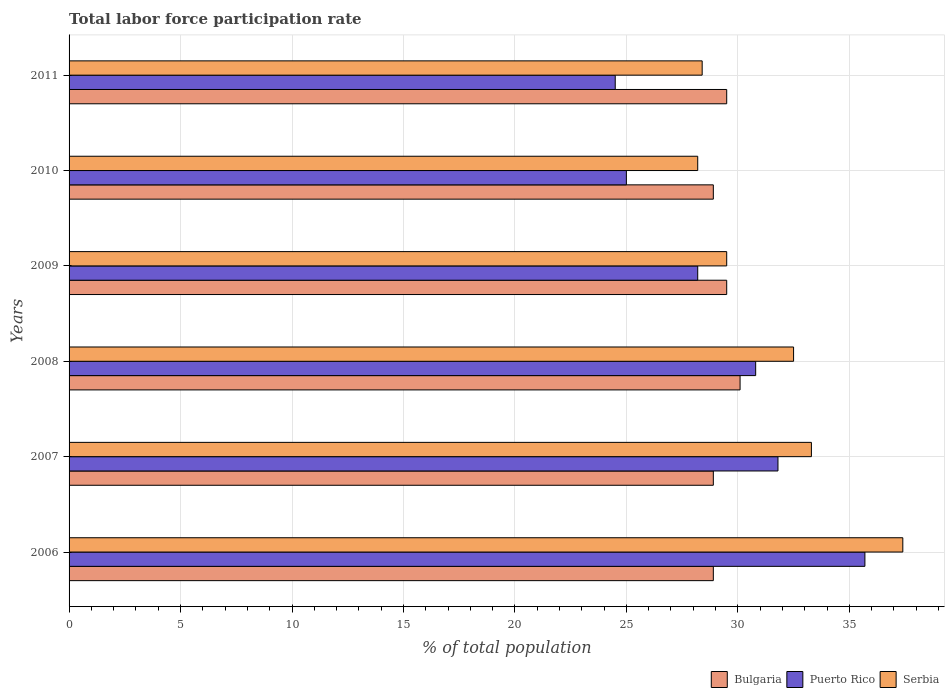How many different coloured bars are there?
Keep it short and to the point. 3. How many groups of bars are there?
Offer a very short reply. 6. How many bars are there on the 2nd tick from the top?
Your answer should be compact. 3. How many bars are there on the 6th tick from the bottom?
Keep it short and to the point. 3. What is the label of the 2nd group of bars from the top?
Provide a succinct answer. 2010. What is the total labor force participation rate in Puerto Rico in 2010?
Your response must be concise. 25. Across all years, what is the maximum total labor force participation rate in Serbia?
Make the answer very short. 37.4. Across all years, what is the minimum total labor force participation rate in Bulgaria?
Your answer should be compact. 28.9. In which year was the total labor force participation rate in Puerto Rico minimum?
Your answer should be compact. 2011. What is the total total labor force participation rate in Bulgaria in the graph?
Offer a terse response. 175.8. What is the difference between the total labor force participation rate in Bulgaria in 2010 and that in 2011?
Your answer should be very brief. -0.6. What is the difference between the total labor force participation rate in Puerto Rico in 2010 and the total labor force participation rate in Bulgaria in 2008?
Make the answer very short. -5.1. What is the average total labor force participation rate in Puerto Rico per year?
Ensure brevity in your answer.  29.33. In the year 2006, what is the difference between the total labor force participation rate in Serbia and total labor force participation rate in Bulgaria?
Keep it short and to the point. 8.5. In how many years, is the total labor force participation rate in Bulgaria greater than 15 %?
Offer a very short reply. 6. What is the ratio of the total labor force participation rate in Bulgaria in 2007 to that in 2011?
Your answer should be compact. 0.98. Is the total labor force participation rate in Serbia in 2006 less than that in 2010?
Provide a succinct answer. No. What is the difference between the highest and the second highest total labor force participation rate in Puerto Rico?
Provide a succinct answer. 3.9. What is the difference between the highest and the lowest total labor force participation rate in Puerto Rico?
Your answer should be very brief. 11.2. In how many years, is the total labor force participation rate in Bulgaria greater than the average total labor force participation rate in Bulgaria taken over all years?
Offer a terse response. 3. Is the sum of the total labor force participation rate in Puerto Rico in 2006 and 2010 greater than the maximum total labor force participation rate in Serbia across all years?
Give a very brief answer. Yes. What does the 1st bar from the top in 2008 represents?
Keep it short and to the point. Serbia. What does the 2nd bar from the bottom in 2007 represents?
Offer a terse response. Puerto Rico. How many bars are there?
Your answer should be very brief. 18. How many years are there in the graph?
Offer a very short reply. 6. What is the difference between two consecutive major ticks on the X-axis?
Your answer should be compact. 5. Where does the legend appear in the graph?
Keep it short and to the point. Bottom right. How are the legend labels stacked?
Ensure brevity in your answer.  Horizontal. What is the title of the graph?
Your answer should be very brief. Total labor force participation rate. What is the label or title of the X-axis?
Make the answer very short. % of total population. What is the % of total population of Bulgaria in 2006?
Make the answer very short. 28.9. What is the % of total population of Puerto Rico in 2006?
Provide a succinct answer. 35.7. What is the % of total population of Serbia in 2006?
Your response must be concise. 37.4. What is the % of total population in Bulgaria in 2007?
Your answer should be compact. 28.9. What is the % of total population in Puerto Rico in 2007?
Ensure brevity in your answer.  31.8. What is the % of total population in Serbia in 2007?
Ensure brevity in your answer.  33.3. What is the % of total population of Bulgaria in 2008?
Provide a succinct answer. 30.1. What is the % of total population of Puerto Rico in 2008?
Offer a very short reply. 30.8. What is the % of total population in Serbia in 2008?
Your answer should be very brief. 32.5. What is the % of total population in Bulgaria in 2009?
Ensure brevity in your answer.  29.5. What is the % of total population in Puerto Rico in 2009?
Ensure brevity in your answer.  28.2. What is the % of total population in Serbia in 2009?
Ensure brevity in your answer.  29.5. What is the % of total population of Bulgaria in 2010?
Offer a terse response. 28.9. What is the % of total population of Serbia in 2010?
Your answer should be very brief. 28.2. What is the % of total population in Bulgaria in 2011?
Offer a very short reply. 29.5. What is the % of total population in Serbia in 2011?
Offer a terse response. 28.4. Across all years, what is the maximum % of total population of Bulgaria?
Your response must be concise. 30.1. Across all years, what is the maximum % of total population of Puerto Rico?
Ensure brevity in your answer.  35.7. Across all years, what is the maximum % of total population of Serbia?
Keep it short and to the point. 37.4. Across all years, what is the minimum % of total population of Bulgaria?
Provide a short and direct response. 28.9. Across all years, what is the minimum % of total population of Puerto Rico?
Provide a succinct answer. 24.5. Across all years, what is the minimum % of total population of Serbia?
Your response must be concise. 28.2. What is the total % of total population of Bulgaria in the graph?
Offer a terse response. 175.8. What is the total % of total population of Puerto Rico in the graph?
Offer a very short reply. 176. What is the total % of total population of Serbia in the graph?
Ensure brevity in your answer.  189.3. What is the difference between the % of total population in Puerto Rico in 2006 and that in 2007?
Make the answer very short. 3.9. What is the difference between the % of total population of Puerto Rico in 2006 and that in 2009?
Give a very brief answer. 7.5. What is the difference between the % of total population of Serbia in 2006 and that in 2009?
Your answer should be compact. 7.9. What is the difference between the % of total population of Bulgaria in 2006 and that in 2010?
Your answer should be compact. 0. What is the difference between the % of total population of Puerto Rico in 2006 and that in 2010?
Provide a short and direct response. 10.7. What is the difference between the % of total population of Serbia in 2006 and that in 2010?
Offer a very short reply. 9.2. What is the difference between the % of total population of Puerto Rico in 2006 and that in 2011?
Ensure brevity in your answer.  11.2. What is the difference between the % of total population of Bulgaria in 2007 and that in 2008?
Your answer should be very brief. -1.2. What is the difference between the % of total population in Puerto Rico in 2007 and that in 2008?
Give a very brief answer. 1. What is the difference between the % of total population in Serbia in 2007 and that in 2008?
Make the answer very short. 0.8. What is the difference between the % of total population in Bulgaria in 2007 and that in 2009?
Your answer should be compact. -0.6. What is the difference between the % of total population in Puerto Rico in 2007 and that in 2009?
Ensure brevity in your answer.  3.6. What is the difference between the % of total population in Bulgaria in 2007 and that in 2010?
Make the answer very short. 0. What is the difference between the % of total population in Serbia in 2007 and that in 2010?
Ensure brevity in your answer.  5.1. What is the difference between the % of total population in Bulgaria in 2007 and that in 2011?
Your answer should be compact. -0.6. What is the difference between the % of total population in Puerto Rico in 2007 and that in 2011?
Offer a terse response. 7.3. What is the difference between the % of total population in Bulgaria in 2008 and that in 2009?
Make the answer very short. 0.6. What is the difference between the % of total population of Serbia in 2008 and that in 2009?
Your answer should be very brief. 3. What is the difference between the % of total population of Puerto Rico in 2008 and that in 2010?
Offer a terse response. 5.8. What is the difference between the % of total population of Bulgaria in 2008 and that in 2011?
Ensure brevity in your answer.  0.6. What is the difference between the % of total population of Serbia in 2009 and that in 2010?
Offer a terse response. 1.3. What is the difference between the % of total population of Puerto Rico in 2009 and that in 2011?
Offer a very short reply. 3.7. What is the difference between the % of total population of Serbia in 2009 and that in 2011?
Ensure brevity in your answer.  1.1. What is the difference between the % of total population in Bulgaria in 2010 and that in 2011?
Give a very brief answer. -0.6. What is the difference between the % of total population in Puerto Rico in 2006 and the % of total population in Serbia in 2007?
Offer a very short reply. 2.4. What is the difference between the % of total population of Bulgaria in 2006 and the % of total population of Serbia in 2008?
Offer a very short reply. -3.6. What is the difference between the % of total population of Puerto Rico in 2006 and the % of total population of Serbia in 2008?
Make the answer very short. 3.2. What is the difference between the % of total population of Bulgaria in 2006 and the % of total population of Puerto Rico in 2009?
Your answer should be very brief. 0.7. What is the difference between the % of total population in Bulgaria in 2006 and the % of total population in Serbia in 2009?
Your answer should be very brief. -0.6. What is the difference between the % of total population of Bulgaria in 2006 and the % of total population of Puerto Rico in 2010?
Your answer should be very brief. 3.9. What is the difference between the % of total population in Puerto Rico in 2006 and the % of total population in Serbia in 2010?
Your response must be concise. 7.5. What is the difference between the % of total population in Bulgaria in 2006 and the % of total population in Puerto Rico in 2011?
Give a very brief answer. 4.4. What is the difference between the % of total population of Bulgaria in 2006 and the % of total population of Serbia in 2011?
Your answer should be compact. 0.5. What is the difference between the % of total population of Puerto Rico in 2006 and the % of total population of Serbia in 2011?
Provide a short and direct response. 7.3. What is the difference between the % of total population in Puerto Rico in 2007 and the % of total population in Serbia in 2008?
Your answer should be compact. -0.7. What is the difference between the % of total population in Bulgaria in 2007 and the % of total population in Puerto Rico in 2009?
Offer a terse response. 0.7. What is the difference between the % of total population of Bulgaria in 2007 and the % of total population of Serbia in 2009?
Offer a very short reply. -0.6. What is the difference between the % of total population of Bulgaria in 2007 and the % of total population of Serbia in 2010?
Provide a short and direct response. 0.7. What is the difference between the % of total population in Bulgaria in 2008 and the % of total population in Serbia in 2009?
Provide a short and direct response. 0.6. What is the difference between the % of total population of Puerto Rico in 2008 and the % of total population of Serbia in 2009?
Offer a very short reply. 1.3. What is the difference between the % of total population of Bulgaria in 2008 and the % of total population of Serbia in 2010?
Ensure brevity in your answer.  1.9. What is the difference between the % of total population in Bulgaria in 2008 and the % of total population in Puerto Rico in 2011?
Provide a succinct answer. 5.6. What is the difference between the % of total population of Bulgaria in 2008 and the % of total population of Serbia in 2011?
Offer a terse response. 1.7. What is the difference between the % of total population of Puerto Rico in 2008 and the % of total population of Serbia in 2011?
Make the answer very short. 2.4. What is the difference between the % of total population in Bulgaria in 2009 and the % of total population in Puerto Rico in 2011?
Offer a very short reply. 5. What is the difference between the % of total population of Bulgaria in 2009 and the % of total population of Serbia in 2011?
Keep it short and to the point. 1.1. What is the difference between the % of total population in Puerto Rico in 2009 and the % of total population in Serbia in 2011?
Your answer should be very brief. -0.2. What is the difference between the % of total population of Puerto Rico in 2010 and the % of total population of Serbia in 2011?
Your answer should be very brief. -3.4. What is the average % of total population of Bulgaria per year?
Keep it short and to the point. 29.3. What is the average % of total population in Puerto Rico per year?
Provide a short and direct response. 29.33. What is the average % of total population of Serbia per year?
Make the answer very short. 31.55. In the year 2006, what is the difference between the % of total population in Bulgaria and % of total population in Puerto Rico?
Provide a short and direct response. -6.8. In the year 2006, what is the difference between the % of total population of Bulgaria and % of total population of Serbia?
Ensure brevity in your answer.  -8.5. In the year 2007, what is the difference between the % of total population in Bulgaria and % of total population in Puerto Rico?
Offer a very short reply. -2.9. In the year 2007, what is the difference between the % of total population of Bulgaria and % of total population of Serbia?
Your answer should be very brief. -4.4. In the year 2007, what is the difference between the % of total population in Puerto Rico and % of total population in Serbia?
Your answer should be very brief. -1.5. In the year 2008, what is the difference between the % of total population in Bulgaria and % of total population in Puerto Rico?
Your answer should be compact. -0.7. In the year 2008, what is the difference between the % of total population of Bulgaria and % of total population of Serbia?
Make the answer very short. -2.4. In the year 2010, what is the difference between the % of total population in Bulgaria and % of total population in Puerto Rico?
Your answer should be very brief. 3.9. In the year 2010, what is the difference between the % of total population of Bulgaria and % of total population of Serbia?
Provide a short and direct response. 0.7. In the year 2010, what is the difference between the % of total population of Puerto Rico and % of total population of Serbia?
Give a very brief answer. -3.2. In the year 2011, what is the difference between the % of total population of Puerto Rico and % of total population of Serbia?
Offer a very short reply. -3.9. What is the ratio of the % of total population in Puerto Rico in 2006 to that in 2007?
Provide a short and direct response. 1.12. What is the ratio of the % of total population in Serbia in 2006 to that in 2007?
Give a very brief answer. 1.12. What is the ratio of the % of total population of Bulgaria in 2006 to that in 2008?
Offer a very short reply. 0.96. What is the ratio of the % of total population of Puerto Rico in 2006 to that in 2008?
Keep it short and to the point. 1.16. What is the ratio of the % of total population of Serbia in 2006 to that in 2008?
Your answer should be very brief. 1.15. What is the ratio of the % of total population in Bulgaria in 2006 to that in 2009?
Provide a succinct answer. 0.98. What is the ratio of the % of total population of Puerto Rico in 2006 to that in 2009?
Give a very brief answer. 1.27. What is the ratio of the % of total population of Serbia in 2006 to that in 2009?
Provide a succinct answer. 1.27. What is the ratio of the % of total population of Bulgaria in 2006 to that in 2010?
Provide a succinct answer. 1. What is the ratio of the % of total population of Puerto Rico in 2006 to that in 2010?
Keep it short and to the point. 1.43. What is the ratio of the % of total population in Serbia in 2006 to that in 2010?
Keep it short and to the point. 1.33. What is the ratio of the % of total population in Bulgaria in 2006 to that in 2011?
Give a very brief answer. 0.98. What is the ratio of the % of total population in Puerto Rico in 2006 to that in 2011?
Your answer should be very brief. 1.46. What is the ratio of the % of total population in Serbia in 2006 to that in 2011?
Your response must be concise. 1.32. What is the ratio of the % of total population in Bulgaria in 2007 to that in 2008?
Your answer should be compact. 0.96. What is the ratio of the % of total population in Puerto Rico in 2007 to that in 2008?
Offer a terse response. 1.03. What is the ratio of the % of total population of Serbia in 2007 to that in 2008?
Offer a very short reply. 1.02. What is the ratio of the % of total population in Bulgaria in 2007 to that in 2009?
Your response must be concise. 0.98. What is the ratio of the % of total population in Puerto Rico in 2007 to that in 2009?
Give a very brief answer. 1.13. What is the ratio of the % of total population of Serbia in 2007 to that in 2009?
Keep it short and to the point. 1.13. What is the ratio of the % of total population in Bulgaria in 2007 to that in 2010?
Make the answer very short. 1. What is the ratio of the % of total population in Puerto Rico in 2007 to that in 2010?
Your response must be concise. 1.27. What is the ratio of the % of total population of Serbia in 2007 to that in 2010?
Offer a very short reply. 1.18. What is the ratio of the % of total population of Bulgaria in 2007 to that in 2011?
Offer a terse response. 0.98. What is the ratio of the % of total population in Puerto Rico in 2007 to that in 2011?
Give a very brief answer. 1.3. What is the ratio of the % of total population of Serbia in 2007 to that in 2011?
Provide a short and direct response. 1.17. What is the ratio of the % of total population of Bulgaria in 2008 to that in 2009?
Offer a terse response. 1.02. What is the ratio of the % of total population of Puerto Rico in 2008 to that in 2009?
Give a very brief answer. 1.09. What is the ratio of the % of total population in Serbia in 2008 to that in 2009?
Your answer should be compact. 1.1. What is the ratio of the % of total population in Bulgaria in 2008 to that in 2010?
Give a very brief answer. 1.04. What is the ratio of the % of total population of Puerto Rico in 2008 to that in 2010?
Make the answer very short. 1.23. What is the ratio of the % of total population in Serbia in 2008 to that in 2010?
Your response must be concise. 1.15. What is the ratio of the % of total population in Bulgaria in 2008 to that in 2011?
Ensure brevity in your answer.  1.02. What is the ratio of the % of total population of Puerto Rico in 2008 to that in 2011?
Your answer should be very brief. 1.26. What is the ratio of the % of total population of Serbia in 2008 to that in 2011?
Your answer should be compact. 1.14. What is the ratio of the % of total population in Bulgaria in 2009 to that in 2010?
Offer a very short reply. 1.02. What is the ratio of the % of total population of Puerto Rico in 2009 to that in 2010?
Give a very brief answer. 1.13. What is the ratio of the % of total population of Serbia in 2009 to that in 2010?
Offer a very short reply. 1.05. What is the ratio of the % of total population in Bulgaria in 2009 to that in 2011?
Give a very brief answer. 1. What is the ratio of the % of total population of Puerto Rico in 2009 to that in 2011?
Your answer should be compact. 1.15. What is the ratio of the % of total population in Serbia in 2009 to that in 2011?
Keep it short and to the point. 1.04. What is the ratio of the % of total population of Bulgaria in 2010 to that in 2011?
Offer a terse response. 0.98. What is the ratio of the % of total population of Puerto Rico in 2010 to that in 2011?
Provide a short and direct response. 1.02. What is the difference between the highest and the second highest % of total population of Bulgaria?
Make the answer very short. 0.6. What is the difference between the highest and the second highest % of total population of Serbia?
Ensure brevity in your answer.  4.1. What is the difference between the highest and the lowest % of total population of Puerto Rico?
Your answer should be compact. 11.2. 